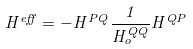<formula> <loc_0><loc_0><loc_500><loc_500>H ^ { e f f } = - H ^ { P Q } \frac { 1 } { H ^ { Q Q } _ { o } } H ^ { Q P }</formula> 